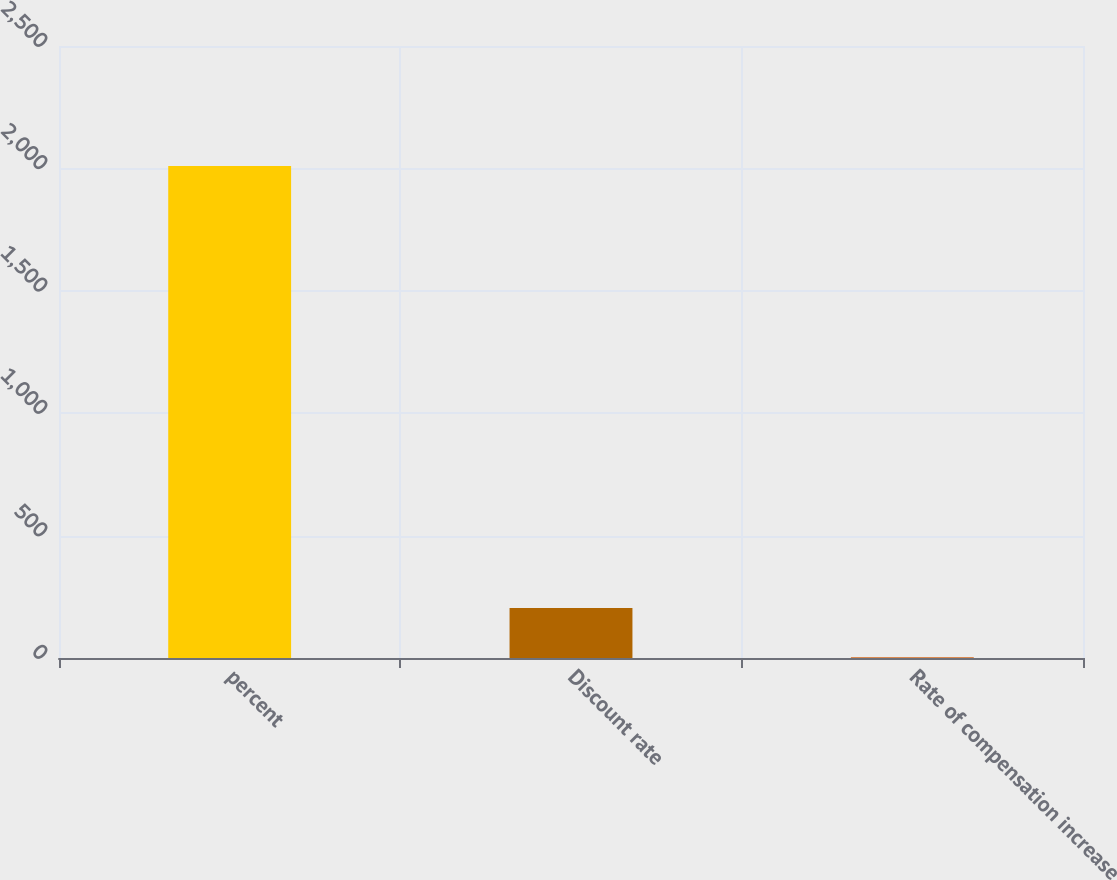Convert chart to OTSL. <chart><loc_0><loc_0><loc_500><loc_500><bar_chart><fcel>percent<fcel>Discount rate<fcel>Rate of compensation increase<nl><fcel>2010<fcel>204.15<fcel>3.5<nl></chart> 